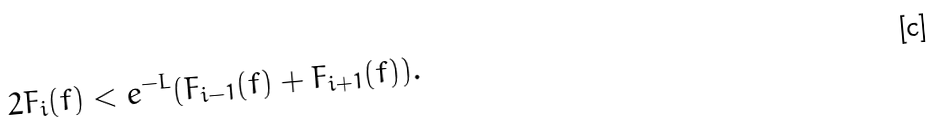Convert formula to latex. <formula><loc_0><loc_0><loc_500><loc_500>2 F _ { i } ( f ) < e ^ { - L } ( F _ { i - 1 } ( f ) + F _ { i + 1 } ( f ) ) .</formula> 